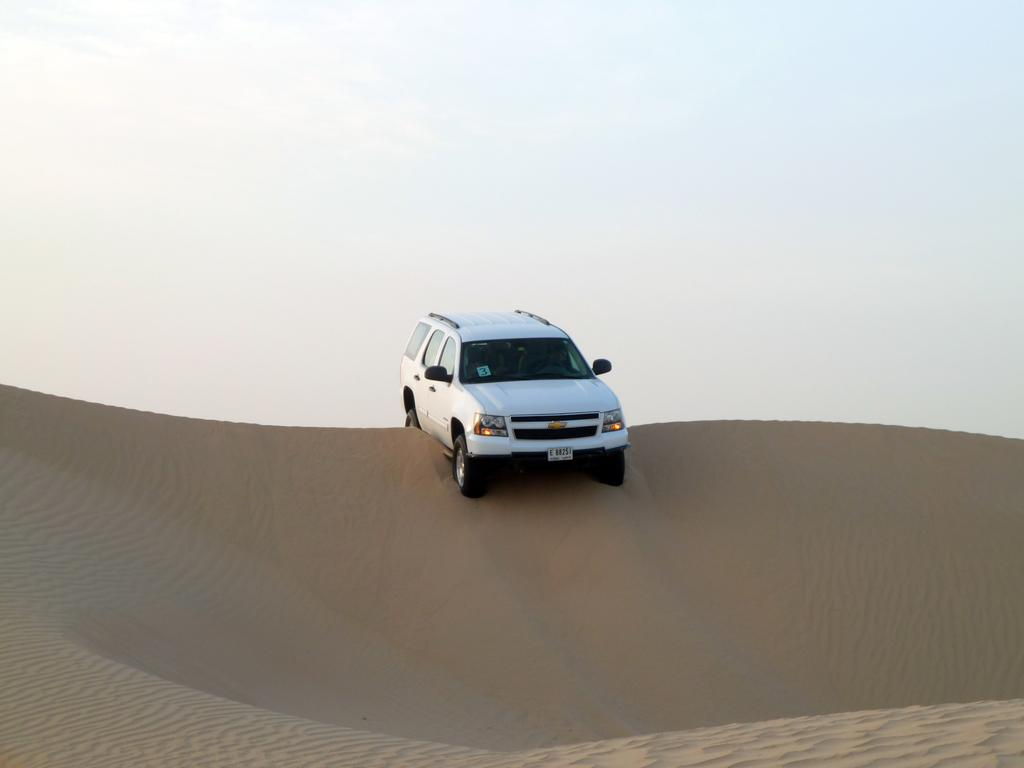What is the main subject in the middle of the image? There is a car in the middle of the image. What type of terrain is visible at the bottom of the image? There is sand at the bottom of the image. What part of the natural environment is visible at the top of the image? The sky is visible at the top of the image. Where is the toothbrush located in the image? There is no toothbrush present in the image. What type of island can be seen in the image? There is no island present in the image. 